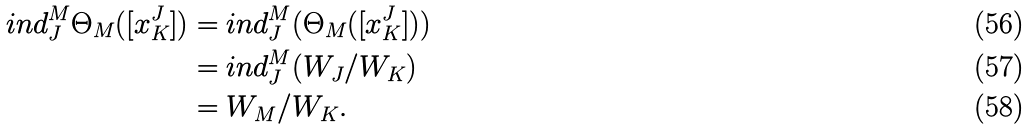Convert formula to latex. <formula><loc_0><loc_0><loc_500><loc_500>{ i n d _ { J } ^ { M } } { \Theta _ { M } } ( [ x _ { K } ^ { J } ] ) & = { i n d _ { J } ^ { M } } ( { \Theta _ { M } } ( [ x _ { K } ^ { J } ] ) ) \\ & = { i n d _ { J } ^ { M } } ( W _ { J } / W _ { K } ) \\ & = W _ { M } / W _ { K } .</formula> 